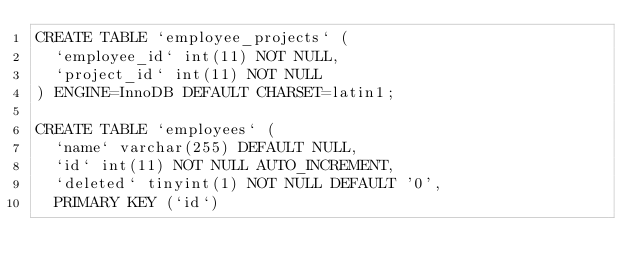<code> <loc_0><loc_0><loc_500><loc_500><_SQL_>CREATE TABLE `employee_projects` (
  `employee_id` int(11) NOT NULL,
  `project_id` int(11) NOT NULL
) ENGINE=InnoDB DEFAULT CHARSET=latin1;

CREATE TABLE `employees` (
  `name` varchar(255) DEFAULT NULL,
  `id` int(11) NOT NULL AUTO_INCREMENT,
  `deleted` tinyint(1) NOT NULL DEFAULT '0',
  PRIMARY KEY (`id`)</code> 